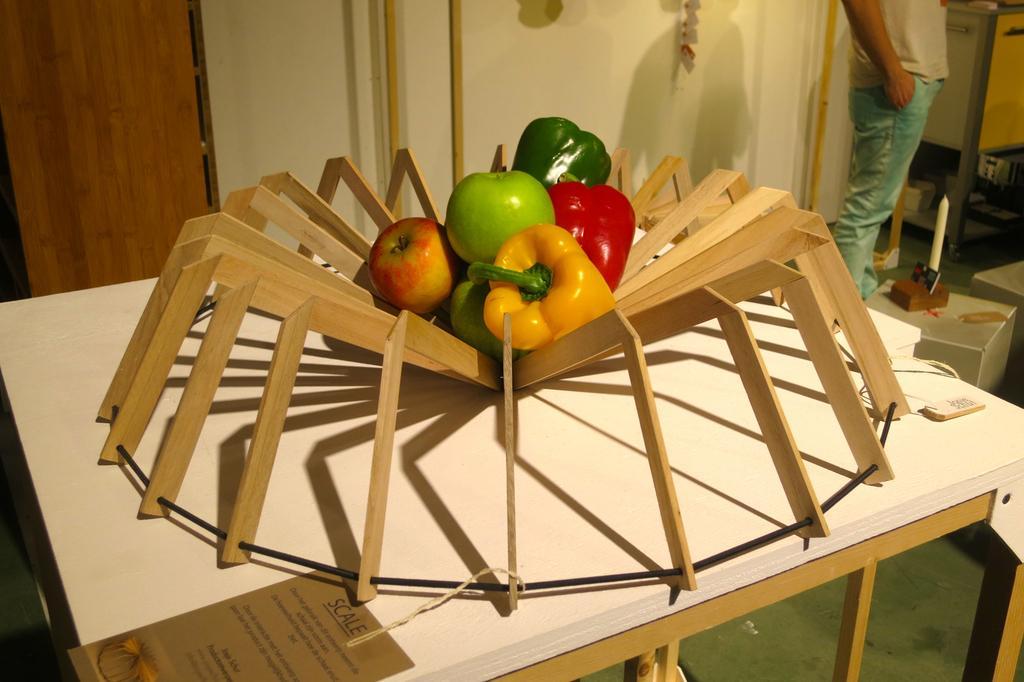How would you summarize this image in a sentence or two? On the table there is a Decorative item with the Wood. Inside that there are fruits and vegetables in it. On the table to the left bottom corner there is a label. And to the right top corner there is a man standing. To the left top corner there is a door. 